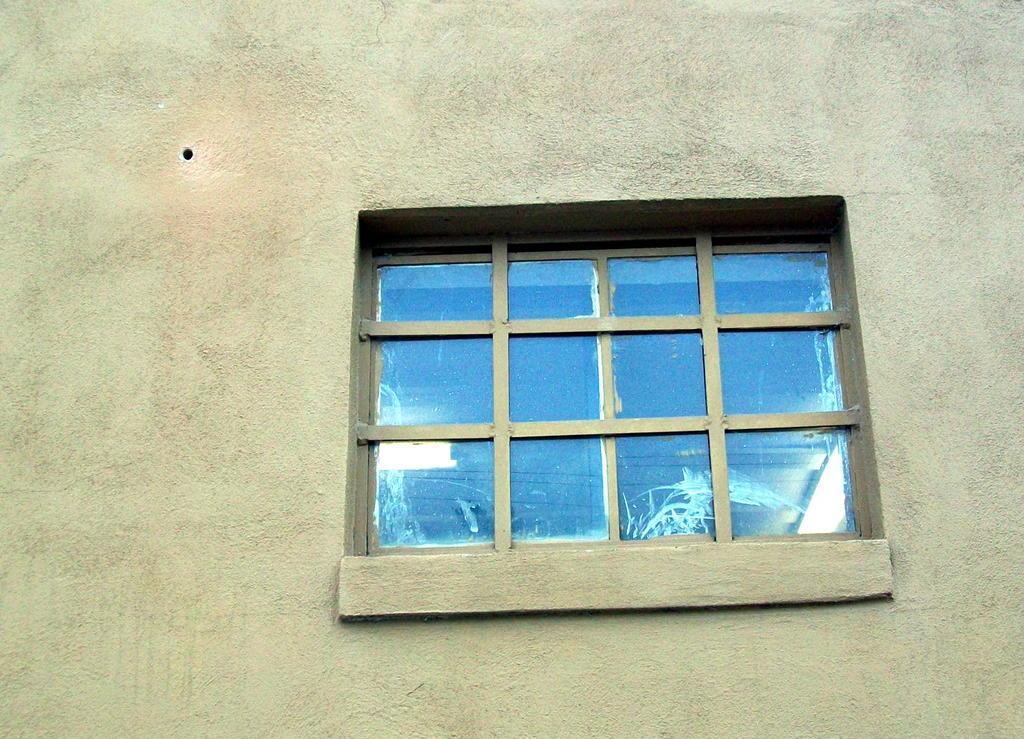In one or two sentences, can you explain what this image depicts? In the image there is a window on the wall. 